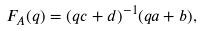Convert formula to latex. <formula><loc_0><loc_0><loc_500><loc_500>F _ { A } ( q ) = ( q c + d ) ^ { - 1 } ( q a + b ) ,</formula> 